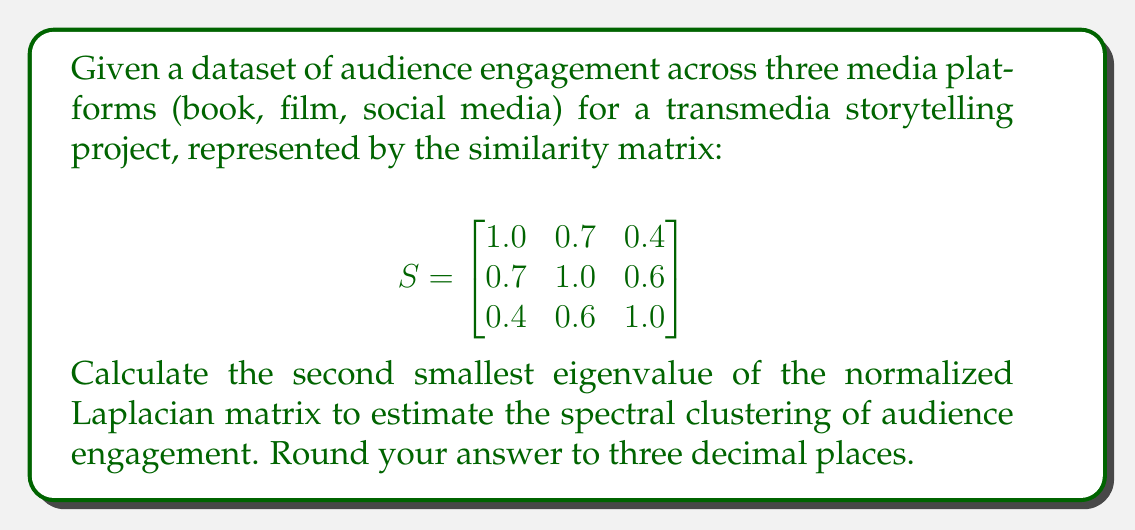Solve this math problem. 1. First, we need to compute the degree matrix $D$:
   $$D = \begin{bmatrix}
   2.1 & 0 & 0 \\
   0 & 2.3 & 0 \\
   0 & 0 & 2.0
   \end{bmatrix}$$

2. Calculate the Laplacian matrix $L = D - S$:
   $$L = \begin{bmatrix}
   1.1 & -0.7 & -0.4 \\
   -0.7 & 1.3 & -0.6 \\
   -0.4 & -0.6 & 1.0
   \end{bmatrix}$$

3. Compute the normalized Laplacian $L_{sym} = D^{-1/2}LD^{-1/2}$:
   $$L_{sym} = \begin{bmatrix}
   1 & -0.4472 & -0.2739 \\
   -0.4472 & 1 & -0.4472 \\
   -0.2739 & -0.4472 & 1
   \end{bmatrix}$$

4. Calculate the eigenvalues of $L_{sym}$:
   $\lambda_1 \approx 0$
   $\lambda_2 \approx 0.5858$
   $\lambda_3 \approx 2.4142$

5. The second smallest eigenvalue is $\lambda_2 \approx 0.5858$

6. Rounding to three decimal places: $0.586$
Answer: 0.586 